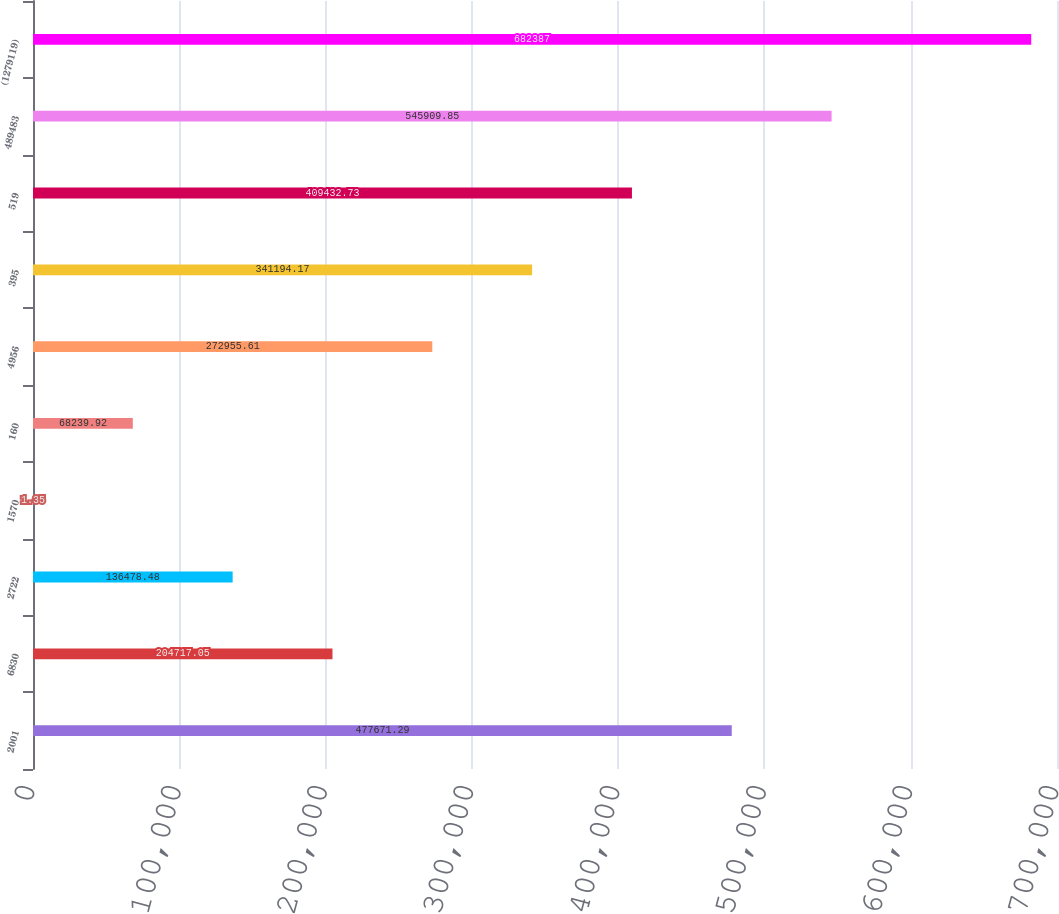Convert chart to OTSL. <chart><loc_0><loc_0><loc_500><loc_500><bar_chart><fcel>2001<fcel>6830<fcel>2722<fcel>1570<fcel>160<fcel>4956<fcel>395<fcel>519<fcel>489483<fcel>(1279119)<nl><fcel>477671<fcel>204717<fcel>136478<fcel>1.35<fcel>68239.9<fcel>272956<fcel>341194<fcel>409433<fcel>545910<fcel>682387<nl></chart> 